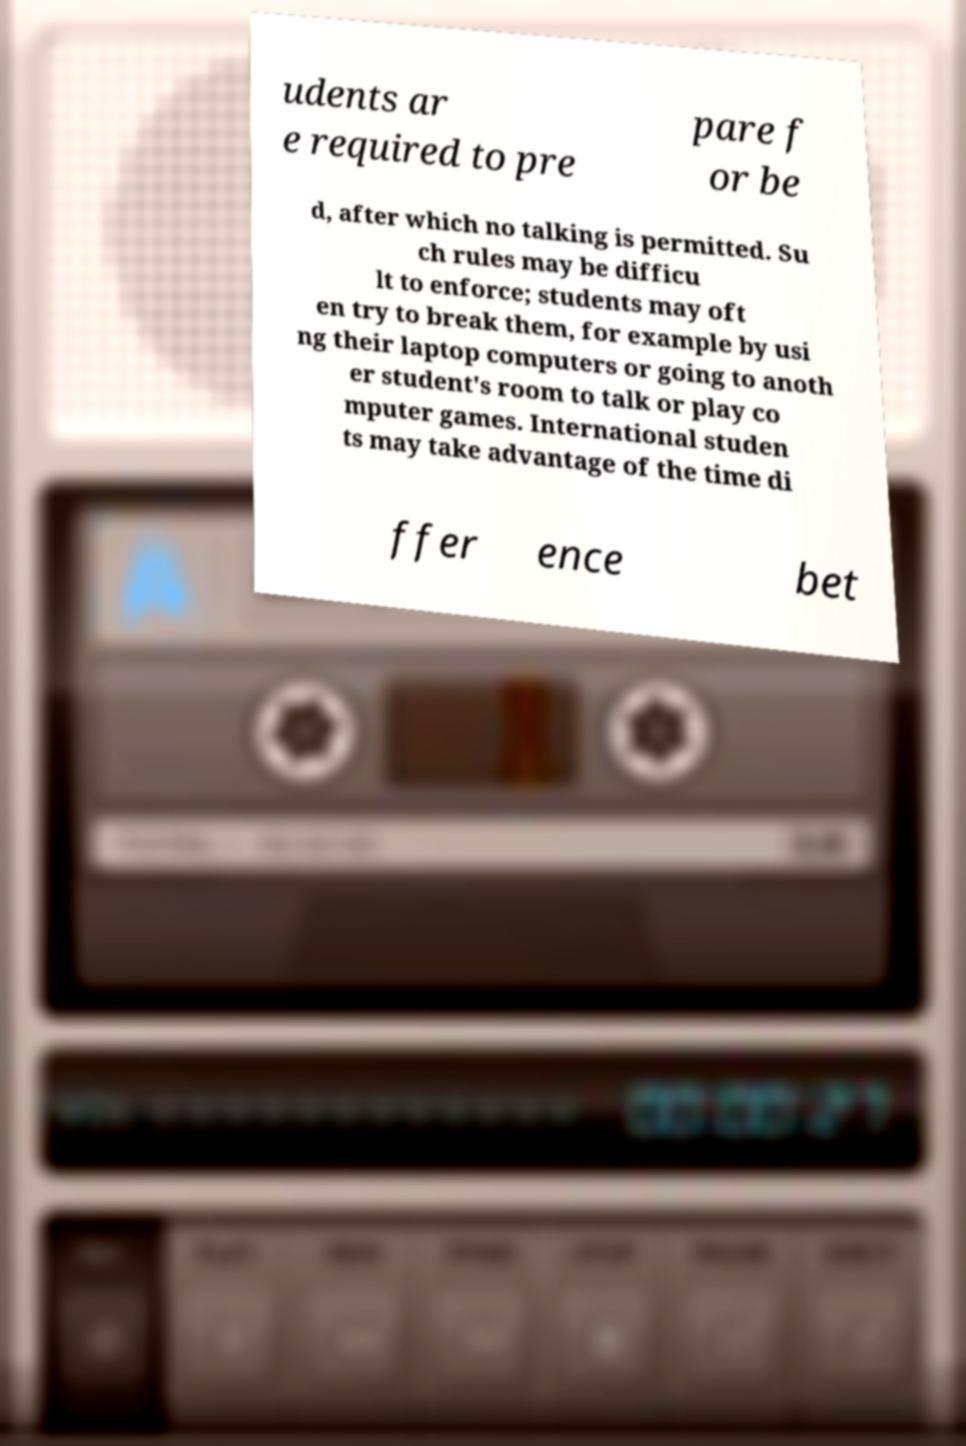What messages or text are displayed in this image? I need them in a readable, typed format. udents ar e required to pre pare f or be d, after which no talking is permitted. Su ch rules may be difficu lt to enforce; students may oft en try to break them, for example by usi ng their laptop computers or going to anoth er student's room to talk or play co mputer games. International studen ts may take advantage of the time di ffer ence bet 